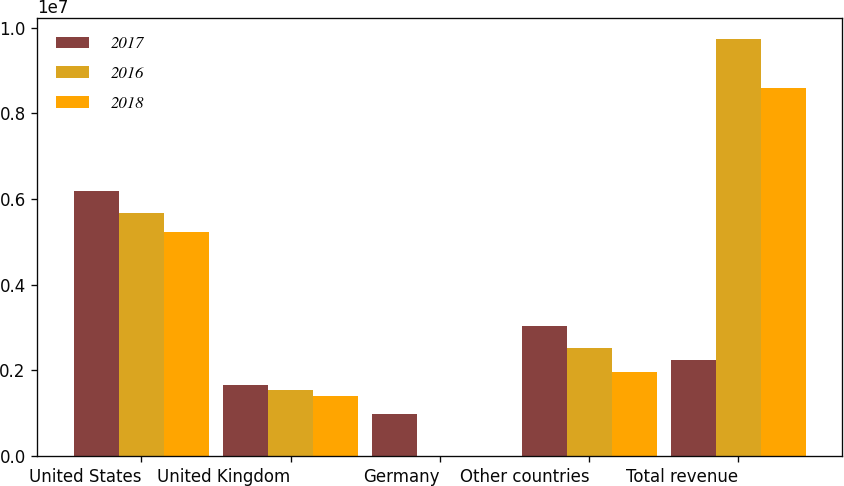Convert chart to OTSL. <chart><loc_0><loc_0><loc_500><loc_500><stacked_bar_chart><ecel><fcel>United States<fcel>United Kingdom<fcel>Germany<fcel>Other countries<fcel>Total revenue<nl><fcel>2017<fcel>6.19264e+06<fcel>1.66532e+06<fcel>974514<fcel>3.04421e+06<fcel>2.24502e+06<nl><fcel>2016<fcel>5.66202e+06<fcel>1.54821e+06<fcel>1744<fcel>2.52494e+06<fcel>9.73691e+06<nl><fcel>2018<fcel>5.22692e+06<fcel>1.39078e+06<fcel>1227<fcel>1.96511e+06<fcel>8.58403e+06<nl></chart> 